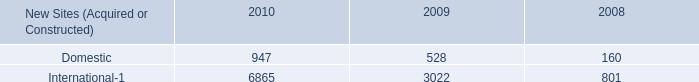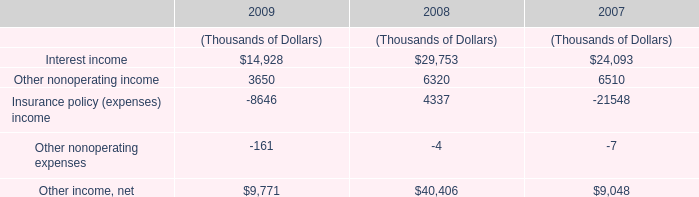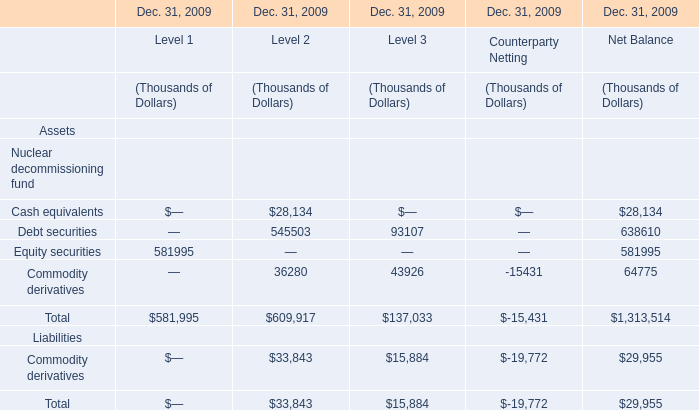What is the average value of Equity securities of Level 1 in Table 2 and Other nonoperating income in Table 1 in 2009? (in thousand) 
Computations: ((581995 + 3650) / 2)
Answer: 292822.5. 